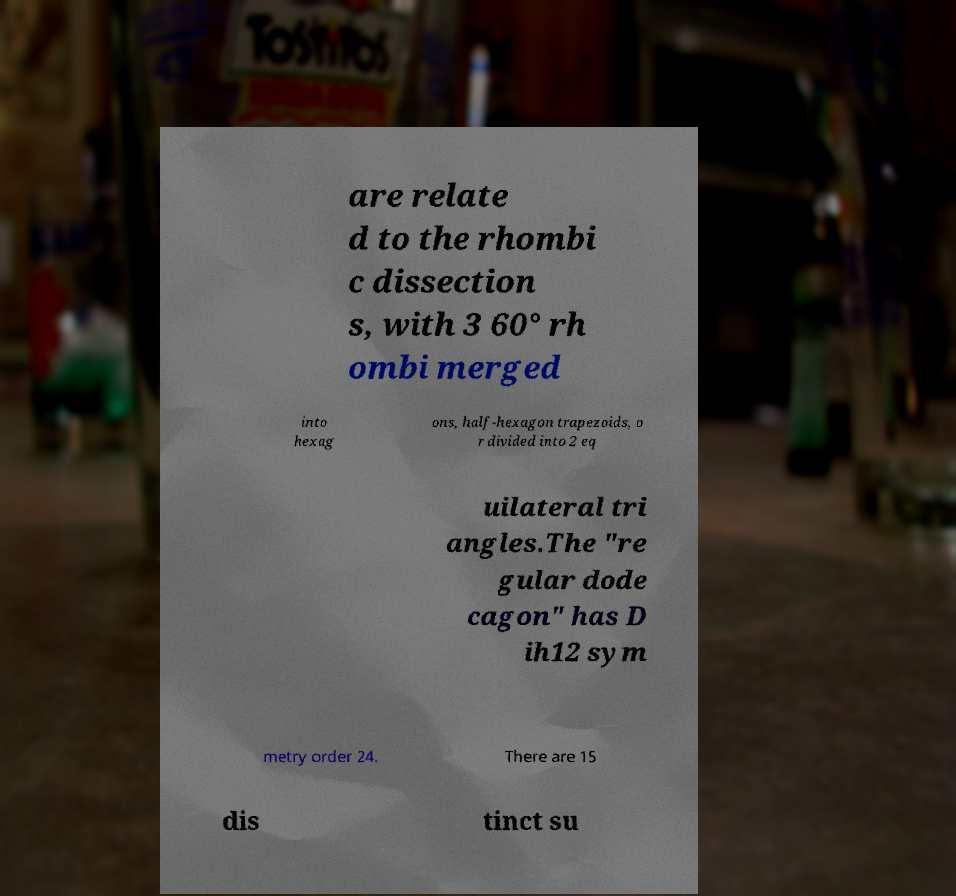For documentation purposes, I need the text within this image transcribed. Could you provide that? are relate d to the rhombi c dissection s, with 3 60° rh ombi merged into hexag ons, half-hexagon trapezoids, o r divided into 2 eq uilateral tri angles.The "re gular dode cagon" has D ih12 sym metry order 24. There are 15 dis tinct su 